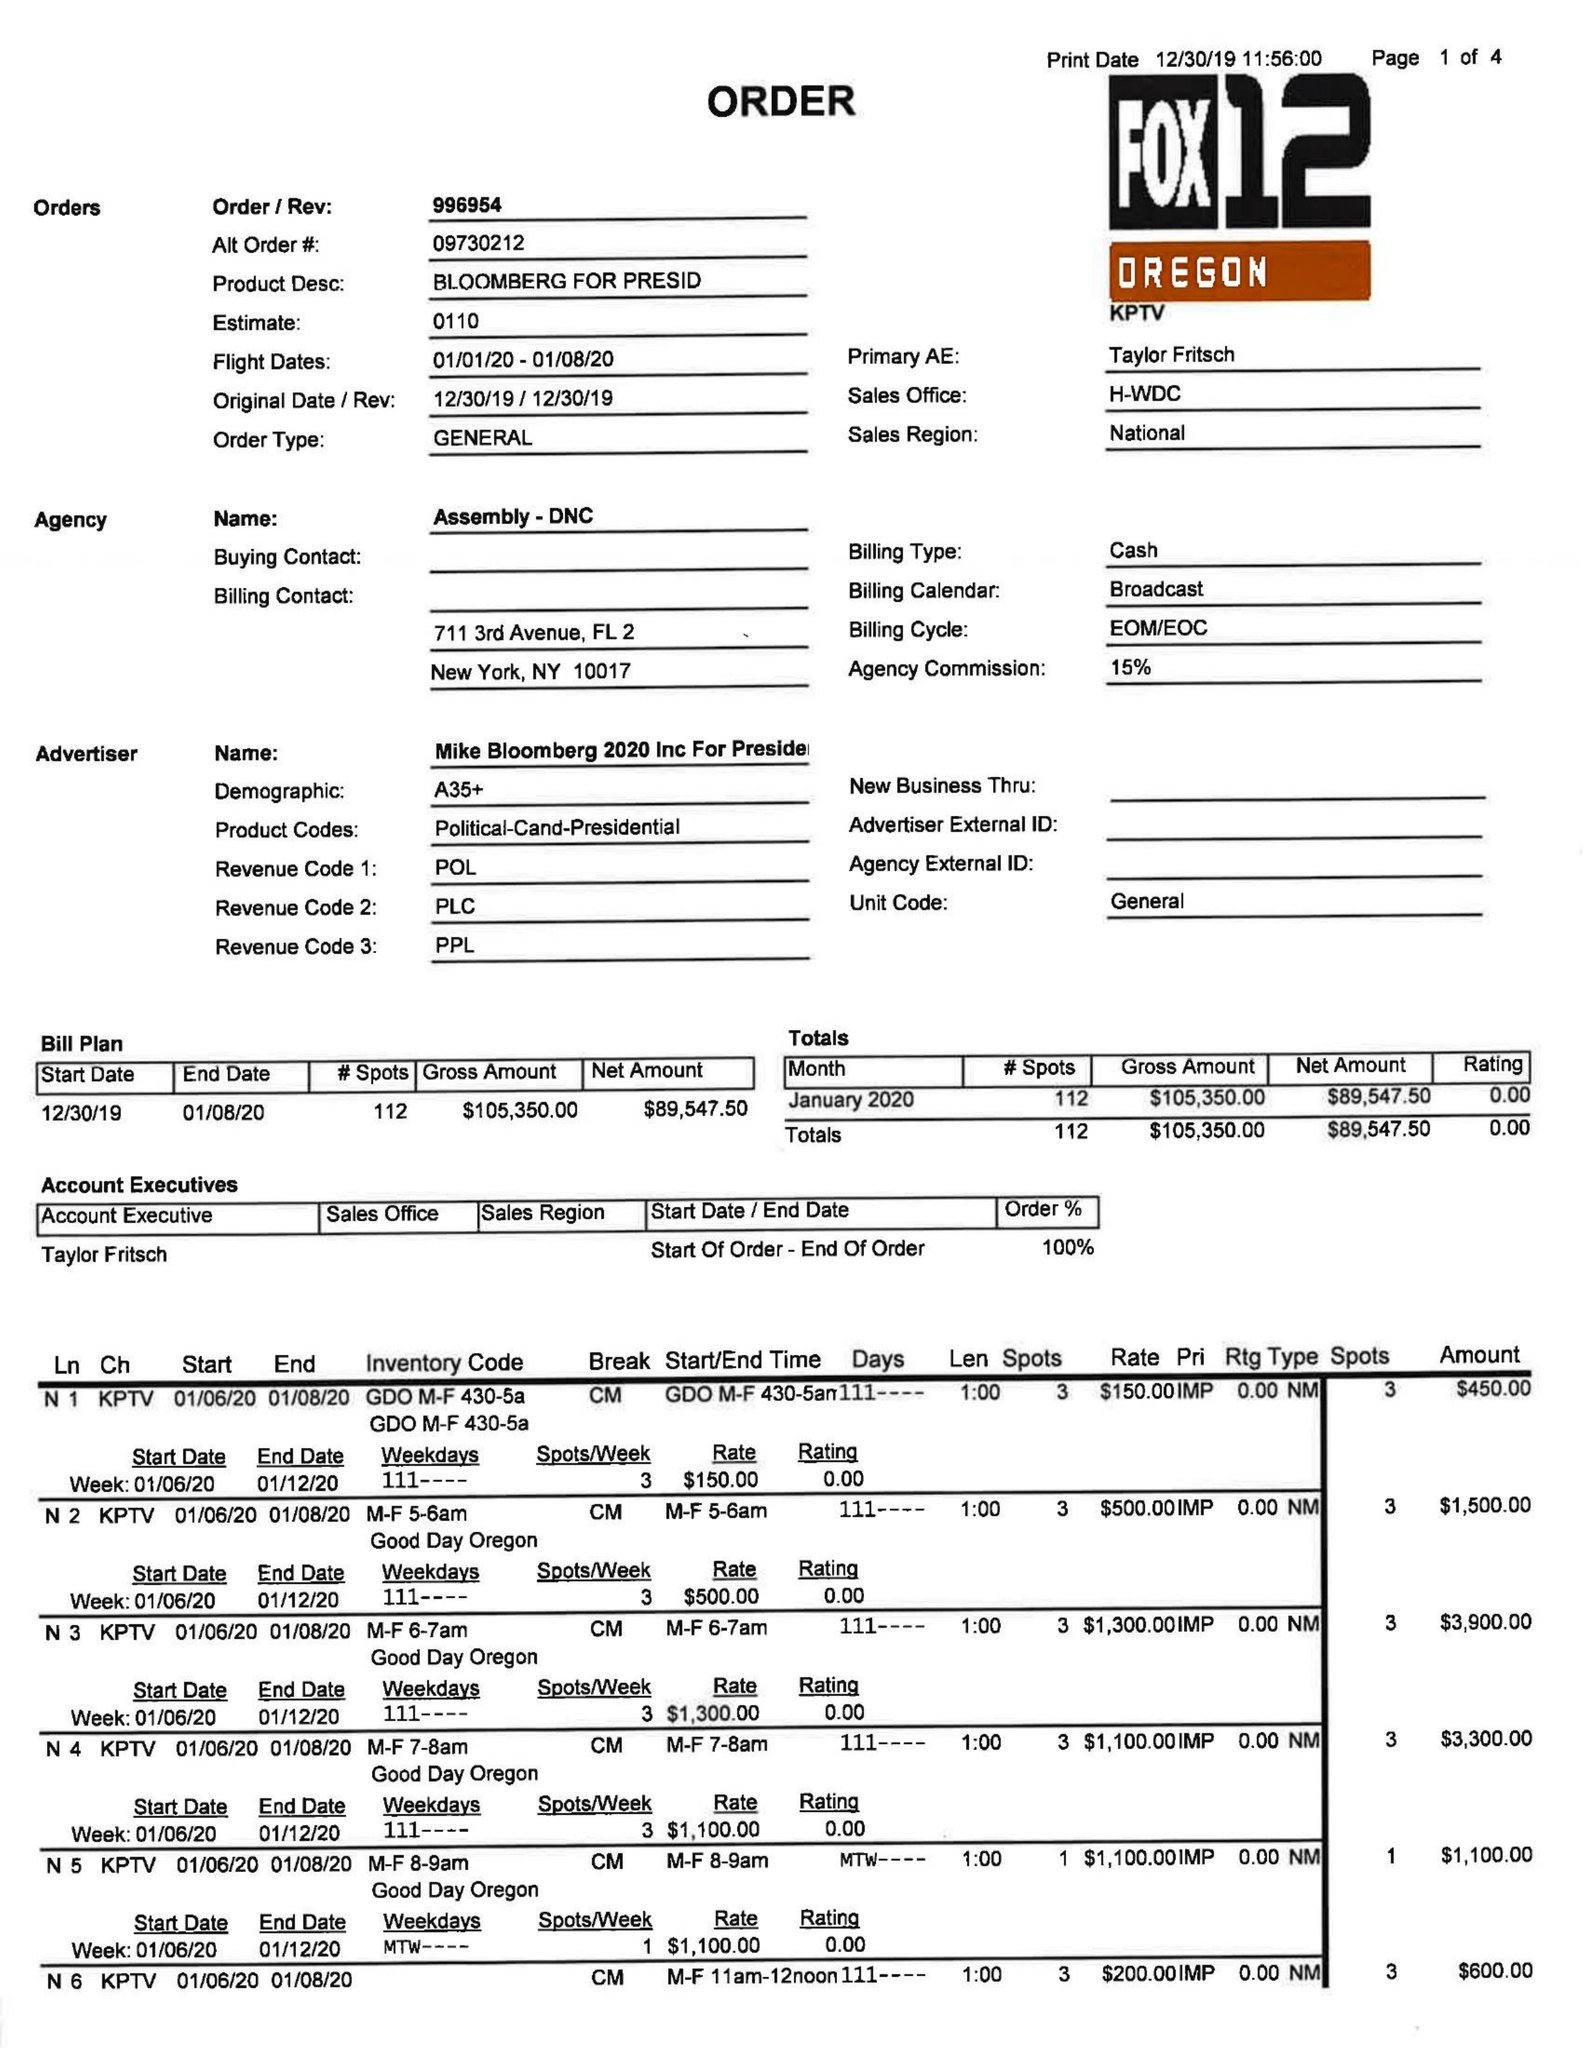What is the value for the gross_amount?
Answer the question using a single word or phrase. 105350.00 